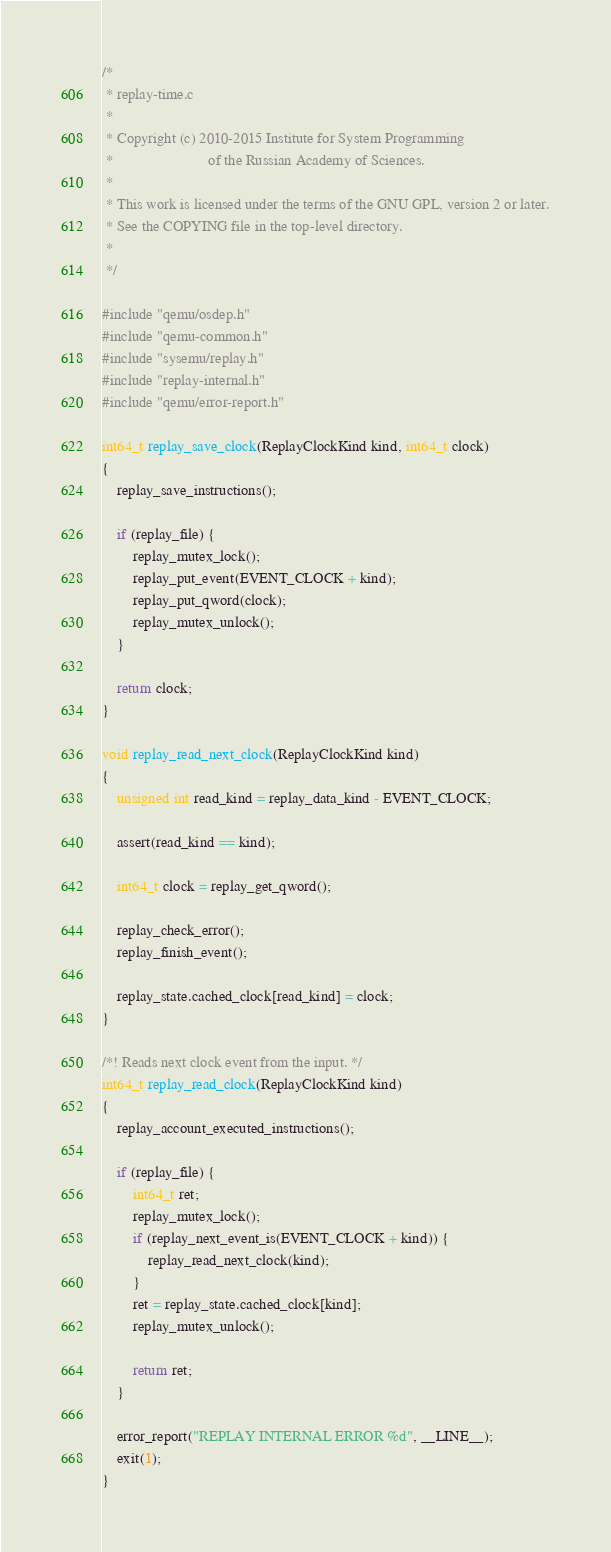<code> <loc_0><loc_0><loc_500><loc_500><_C_>/*
 * replay-time.c
 *
 * Copyright (c) 2010-2015 Institute for System Programming
 *                         of the Russian Academy of Sciences.
 *
 * This work is licensed under the terms of the GNU GPL, version 2 or later.
 * See the COPYING file in the top-level directory.
 *
 */

#include "qemu/osdep.h"
#include "qemu-common.h"
#include "sysemu/replay.h"
#include "replay-internal.h"
#include "qemu/error-report.h"

int64_t replay_save_clock(ReplayClockKind kind, int64_t clock)
{
    replay_save_instructions();

    if (replay_file) {
        replay_mutex_lock();
        replay_put_event(EVENT_CLOCK + kind);
        replay_put_qword(clock);
        replay_mutex_unlock();
    }

    return clock;
}

void replay_read_next_clock(ReplayClockKind kind)
{
    unsigned int read_kind = replay_data_kind - EVENT_CLOCK;

    assert(read_kind == kind);

    int64_t clock = replay_get_qword();

    replay_check_error();
    replay_finish_event();

    replay_state.cached_clock[read_kind] = clock;
}

/*! Reads next clock event from the input. */
int64_t replay_read_clock(ReplayClockKind kind)
{
    replay_account_executed_instructions();

    if (replay_file) {
        int64_t ret;
        replay_mutex_lock();
        if (replay_next_event_is(EVENT_CLOCK + kind)) {
            replay_read_next_clock(kind);
        }
        ret = replay_state.cached_clock[kind];
        replay_mutex_unlock();

        return ret;
    }

    error_report("REPLAY INTERNAL ERROR %d", __LINE__);
    exit(1);
}
</code> 